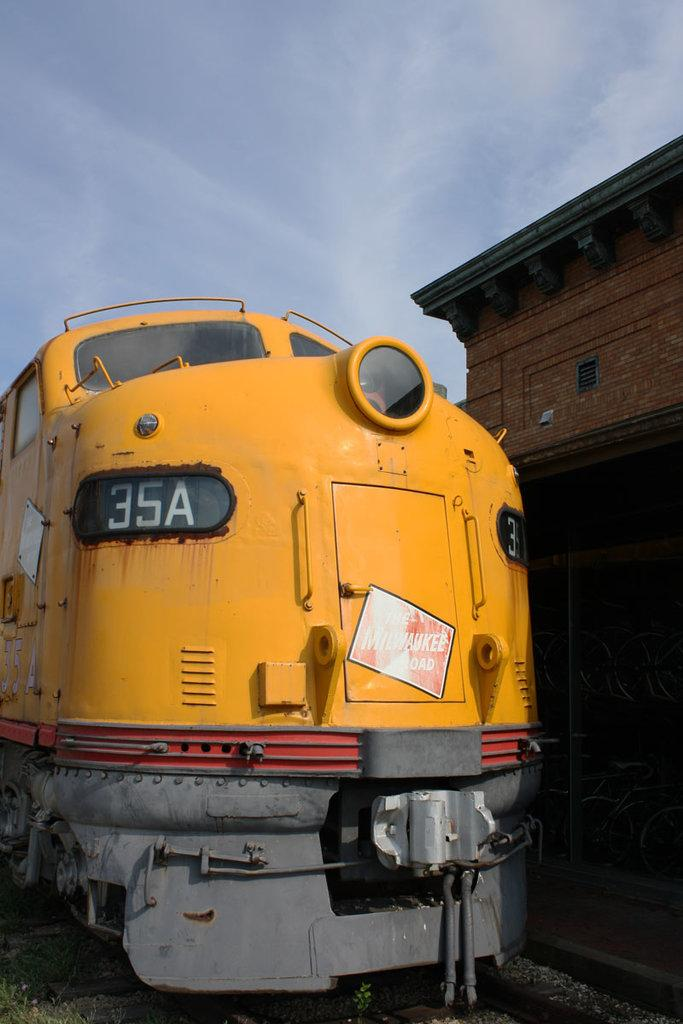<image>
Describe the image concisely. Yellow train with 35A in the front parked outside. 